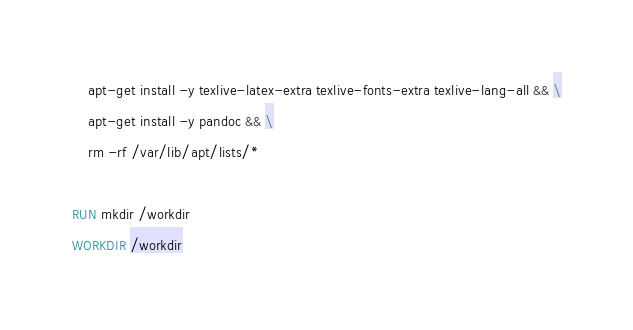Convert code to text. <code><loc_0><loc_0><loc_500><loc_500><_Dockerfile_>    apt-get install -y texlive-latex-extra texlive-fonts-extra texlive-lang-all && \
    apt-get install -y pandoc && \
    rm -rf /var/lib/apt/lists/*

RUN mkdir /workdir
WORKDIR /workdir</code> 